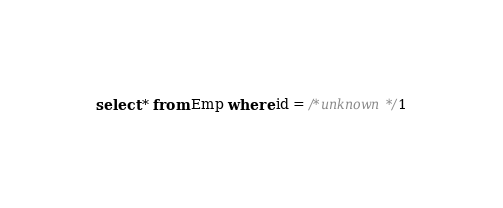<code> <loc_0><loc_0><loc_500><loc_500><_SQL_>select * from Emp where id = /*unknown*/1</code> 